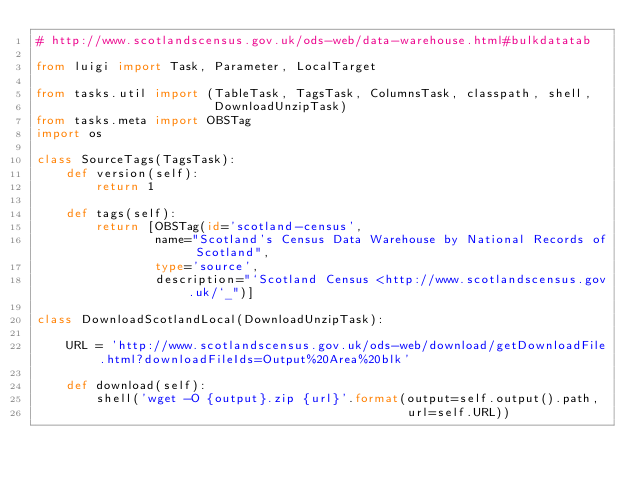Convert code to text. <code><loc_0><loc_0><loc_500><loc_500><_Python_># http://www.scotlandscensus.gov.uk/ods-web/data-warehouse.html#bulkdatatab

from luigi import Task, Parameter, LocalTarget

from tasks.util import (TableTask, TagsTask, ColumnsTask, classpath, shell,
                        DownloadUnzipTask)
from tasks.meta import OBSTag
import os

class SourceTags(TagsTask):
    def version(self):
        return 1

    def tags(self):
        return [OBSTag(id='scotland-census',
                name="Scotland's Census Data Warehouse by National Records of Scotland",
                type='source',
                description="`Scotland Census <http://www.scotlandscensus.gov.uk/`_")]

class DownloadScotlandLocal(DownloadUnzipTask):

    URL = 'http://www.scotlandscensus.gov.uk/ods-web/download/getDownloadFile.html?downloadFileIds=Output%20Area%20blk'

    def download(self):
        shell('wget -O {output}.zip {url}'.format(output=self.output().path,
                                                  url=self.URL))
</code> 